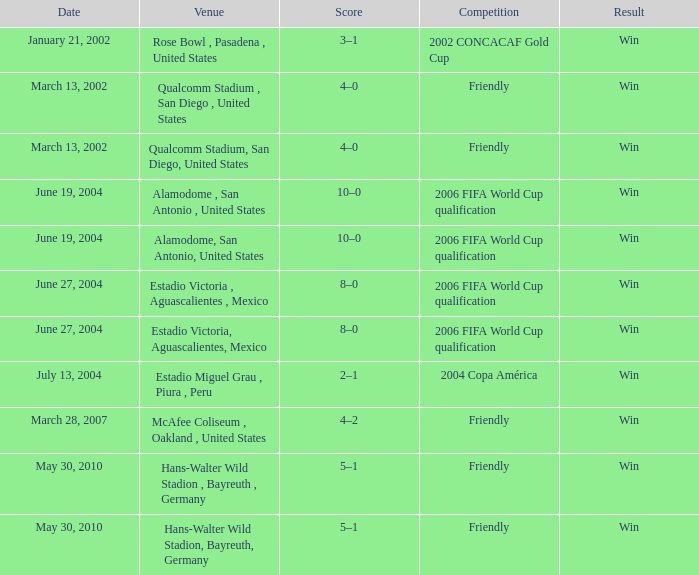What date has 2006 fifa world cup qualification as the competition, and alamodome, san antonio, united States as the venue? June 19, 2004, June 19, 2004. 